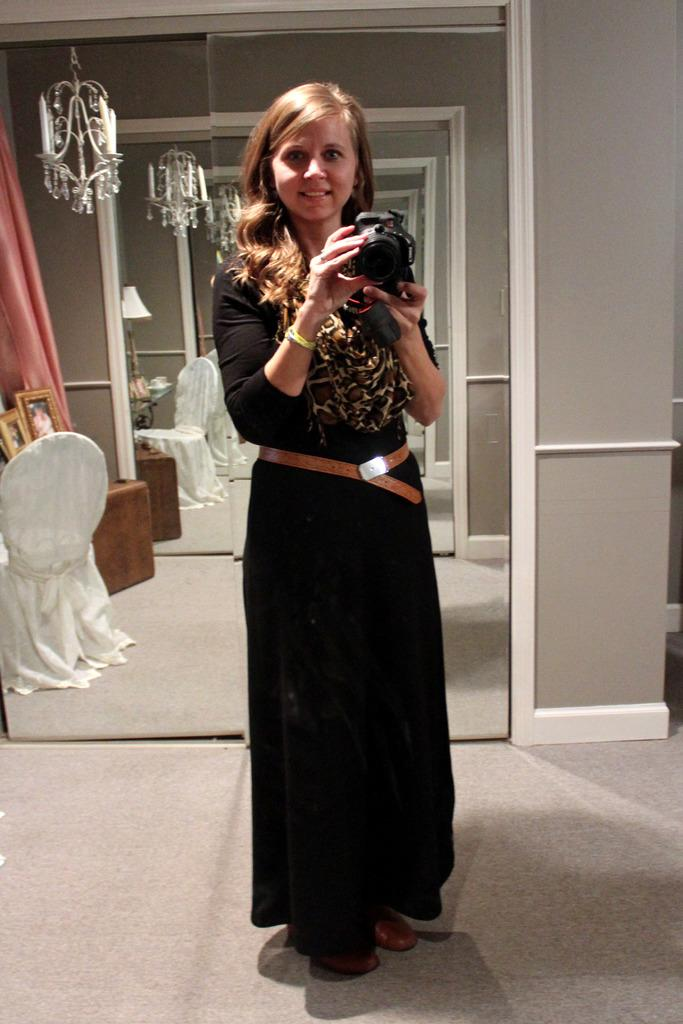Who is present in the image? There is a woman in the image. What is the woman holding in her hands? The woman is holding a camera in her hands. What is the woman's emotional state in the image? The woman is smiling in the image. What can be seen in the background of the image? There is a mirror, chairs, and a lamp visible in the image. What type of surface is visible in the image? There is a floor visible in the image. Can you see a dog wearing underwear in the image? No, there is no dog or underwear present in the image. 